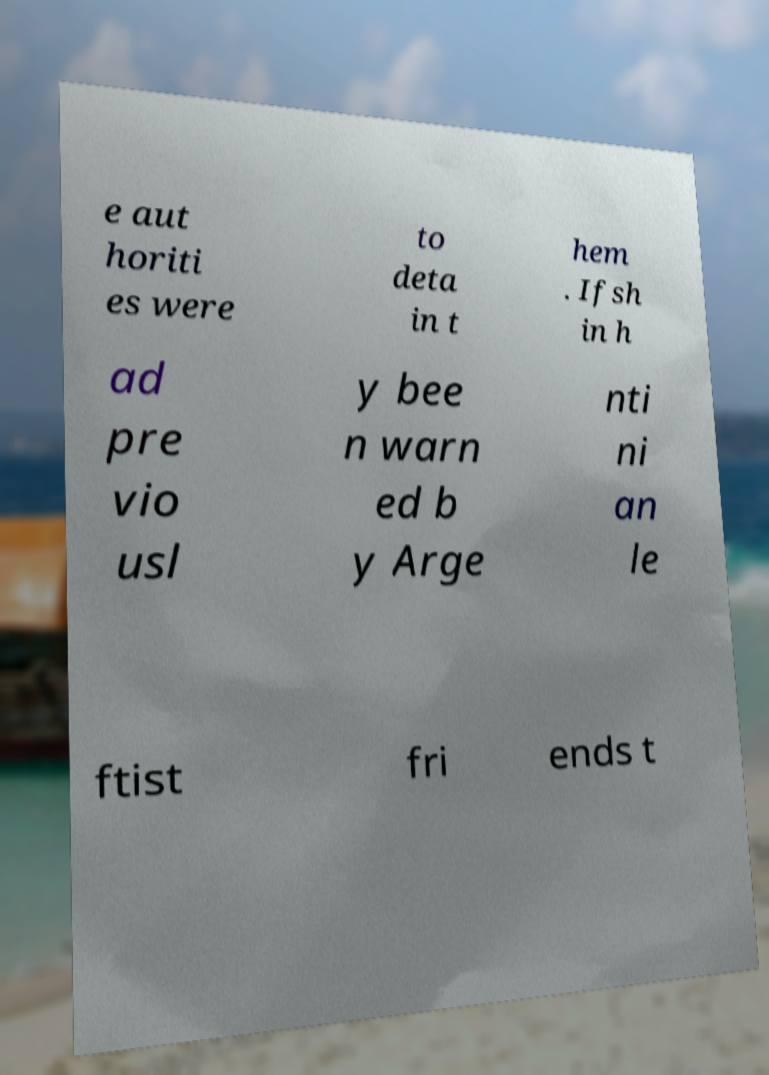Could you assist in decoding the text presented in this image and type it out clearly? e aut horiti es were to deta in t hem . Ifsh in h ad pre vio usl y bee n warn ed b y Arge nti ni an le ftist fri ends t 